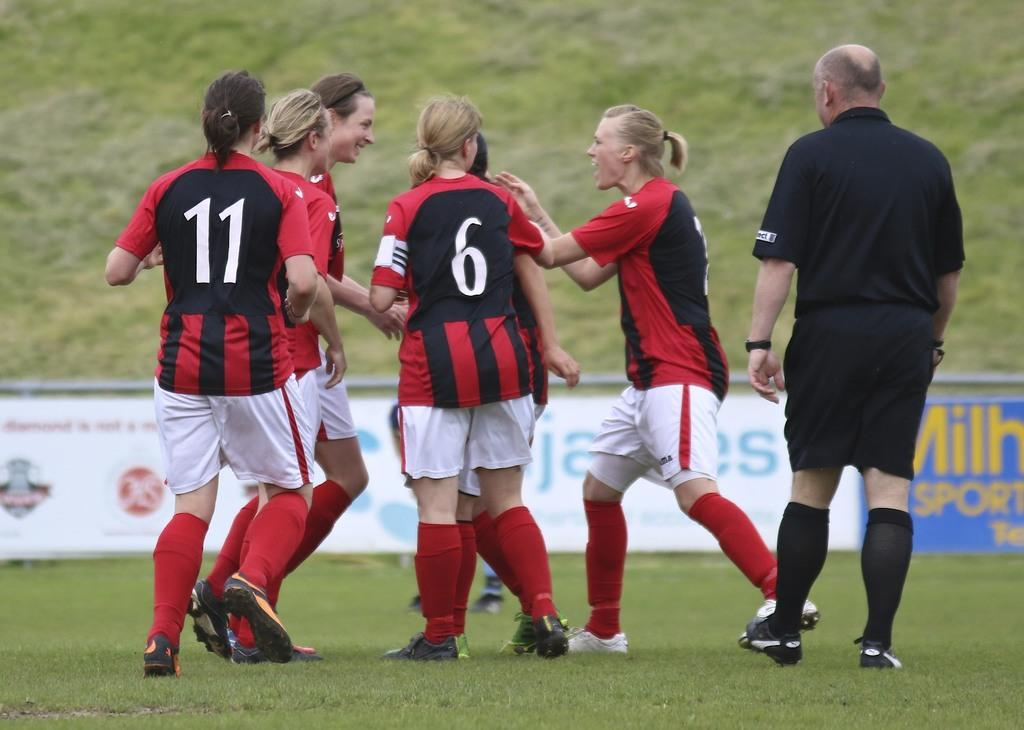Provide a one-sentence caption for the provided image. Number 6 from a soccer team has her back facing the camera. 